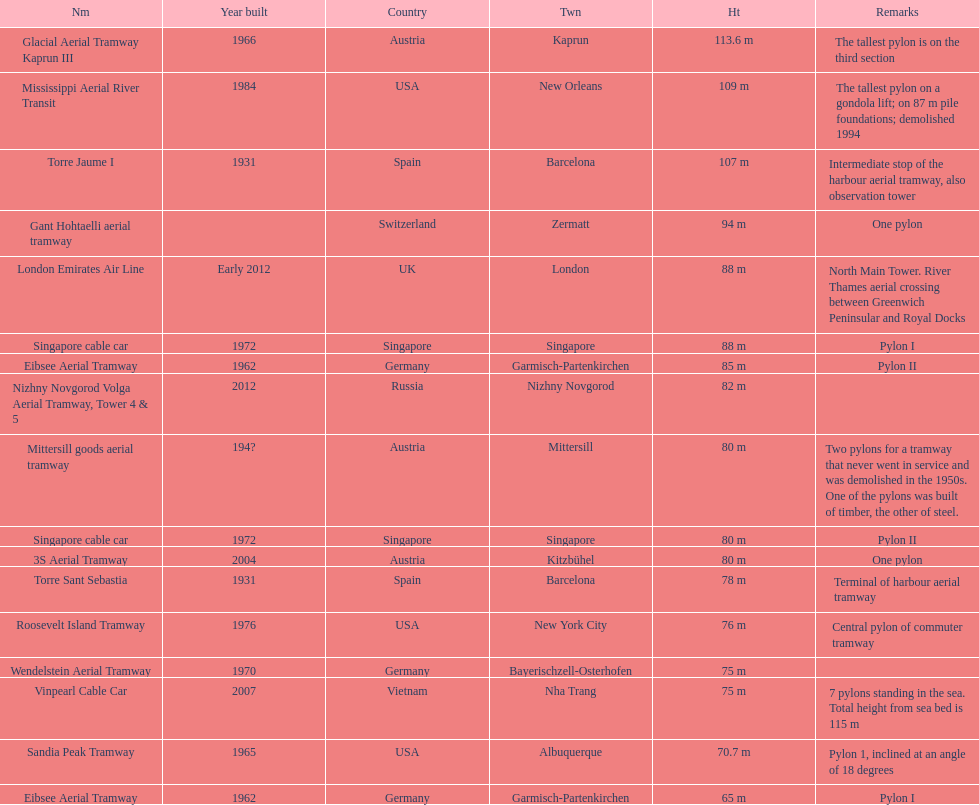How many metres is the mississippi aerial river transit from bottom to top? 109 m. 